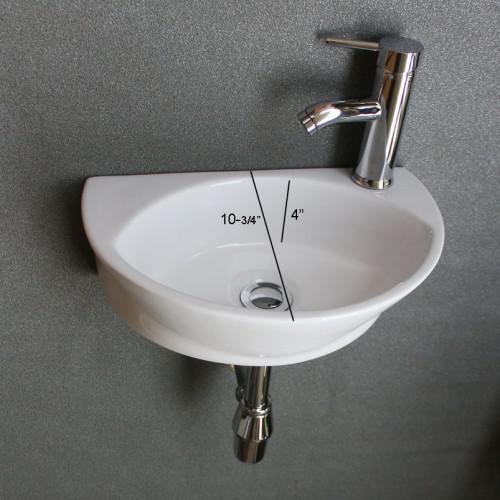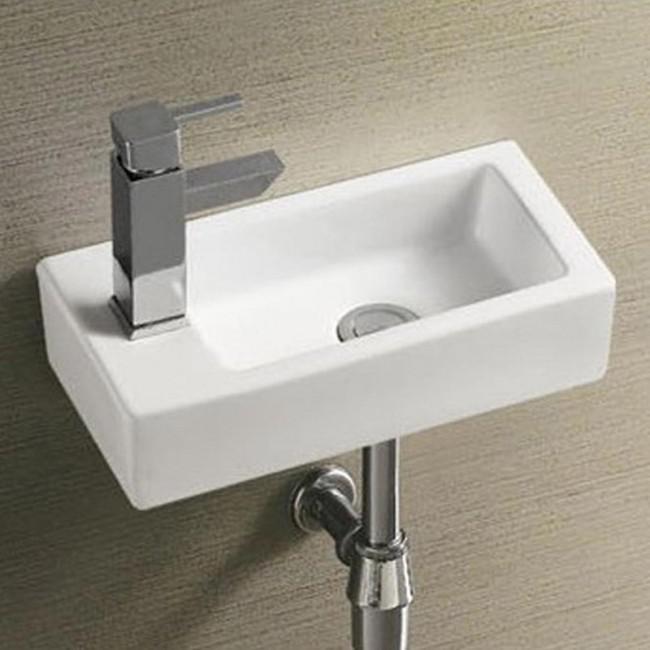The first image is the image on the left, the second image is the image on the right. Assess this claim about the two images: "There is one oval shaped sink and one rectangle shaped sink attached to the wall.". Correct or not? Answer yes or no. Yes. The first image is the image on the left, the second image is the image on the right. Given the left and right images, does the statement "An image features a wall-mounted semi-circle white sinkwith chrome dispenser on top." hold true? Answer yes or no. Yes. 